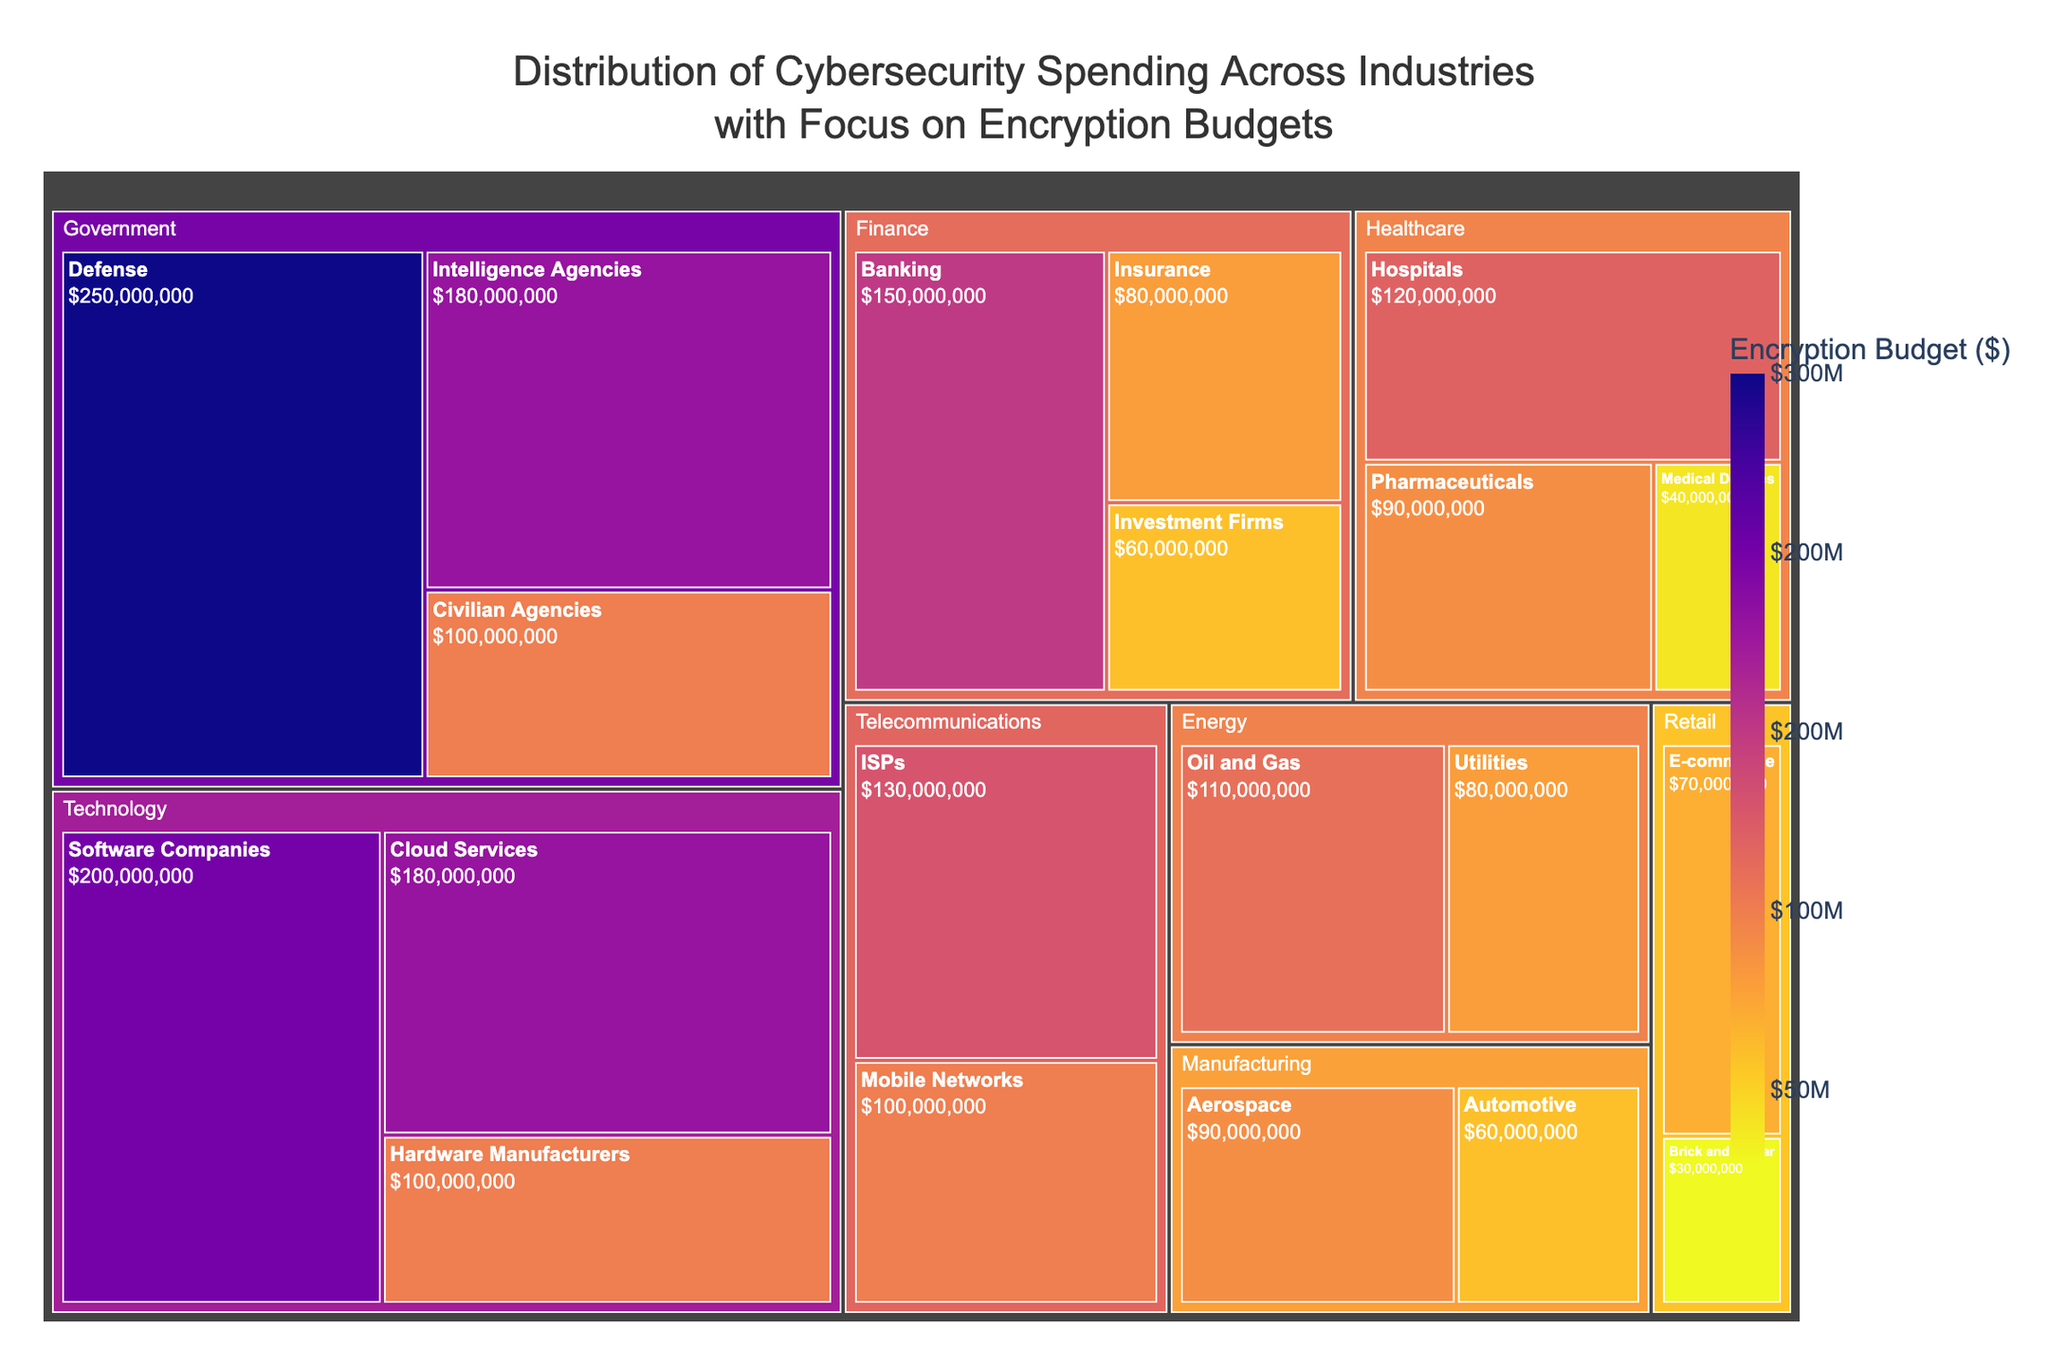What's the industry with the largest encryption budget? The largest block in the treemap, representing the largest encryption budget, belongs to the Technology industry, specifically Software Companies with $200,000,000.
Answer: Technology How much is the encryption budget for Defense within the Government sector? Navigate to the Government sector and find the Defense subsector. The identified block indicates an encryption budget of $250,000,000.
Answer: $250,000,000 Which industry has the smallest encryption budget and what is the amount? The smallest block in the treemap belongs to Retail's Brick and Mortar, with an encryption budget of $30,000,000.
Answer: Retail's Brick and Mortar, $30,000,000 What is the total encryption budget for the Finance industry? The Finance industry has three sectors: Banking ($150,000,000), Insurance ($80,000,000), and Investment Firms ($60,000,000). Summing these values gives: $150,000,000 + $80,000,000 + $60,000,000 = $290,000,000.
Answer: $290,000,000 How does the Healthcare industry's budget compare to the Technology industry's budget in encryption spending? The Healthcare industry (sum of Hospitals $120,000,000, Pharmaceuticals $90,000,000, and Medical Devices $40,000,000) totals to $250,000,000, while Technology's sectors (Software Companies $200,000,000, Hardware Manufacturers $100,000,000, Cloud Services $180,000,000) total to $480,000,000. Therefore, Technology has a higher budget than Healthcare.
Answer: Technology has a higher budget Which sector within the Government industry has the second-highest encryption budget? Within the Government industry, the sectors are Defense ($250,000,000), Intelligence Agencies ($180,000,000), and Civilian Agencies ($100,000,000). The second-highest is Intelligence Agencies with $180,000,000.
Answer: Intelligence Agencies What's the total encryption budget for the Technology and Energy industries combined? Technology (sum of Software Companies $200,000,000, Hardware Manufacturers $100,000,000, Cloud Services $180,000,000) is $480,000,000. Energy (Oil and Gas $110,000,000, Utilities $80,000,000) is $190,000,000. Summing them gives: $480,000,000 + $190,000,000 = $670,000,000.
Answer: $670,000,000 What is the average encryption budget of the sectors within the Telecommunications industry? Telecommunications has two sectors: ISPs ($130,000,000) and Mobile Networks ($100,000,000). Their average budget is calculated as: ($130,000,000 + $100,000,000) / 2 = $115,000,000.
Answer: $115,000,000 Identify all sectors that have an encryption budget greater than $100,000,000. The sectors greater than $100,000,000 are Banking ($150,000,000), Hospitals ($120,000,000), Software Companies ($200,000,000), Cloud Services ($180,000,000), Defense ($250,000,000), Intelligence Agencies ($180,000,000), ISPs ($130,000,000), and Oil and Gas ($110,000,000).
Answer: Banking, Hospitals, Software Companies, Cloud Services, Defense, Intelligence Agencies, ISPs, Oil and Gas 